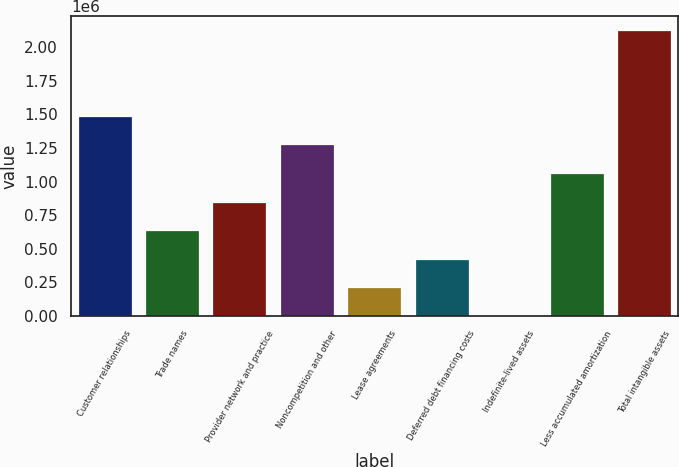Convert chart. <chart><loc_0><loc_0><loc_500><loc_500><bar_chart><fcel>Customer relationships<fcel>Trade names<fcel>Provider network and practice<fcel>Noncompetition and other<fcel>Lease agreements<fcel>Deferred debt financing costs<fcel>Indefinite-lived assets<fcel>Less accumulated amortization<fcel>Total intangible assets<nl><fcel>1.48991e+06<fcel>638969<fcel>851704<fcel>1.27718e+06<fcel>213498<fcel>426233<fcel>762<fcel>1.06444e+06<fcel>2.12812e+06<nl></chart> 